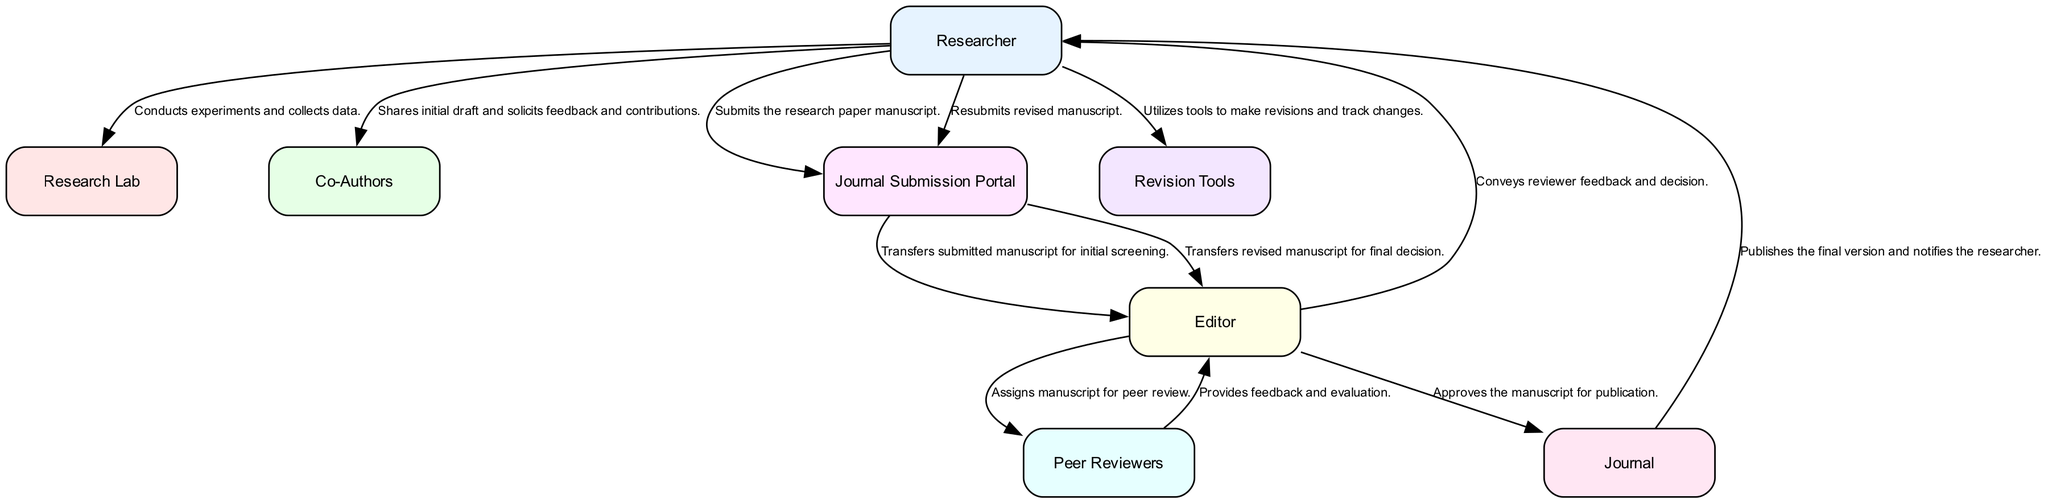What is the role of the Researcher in the diagram? The Researcher initiates the journey of the research paper by conceiving ideas, collecting data, drafting the manuscript, and later, responding to feedback and making revisions.
Answer: Initiator of the research paper How many entities are represented in the diagram? The diagram shows a total of eight entities that play a role in the journey of the research paper from concept to publication.
Answer: Eight What is the first flow of data in the process? The first flow involves the Researcher conducting experiments and collecting data, which is represented as the initial action in the diagram.
Answer: Conducts experiments and collects data Which entity receives feedback from the Peer Reviewers? The Editor receives evaluation and feedback from Peer Reviewers, which is an essential step before communicating with the Researcher.
Answer: Editor What tool does the Researcher use to make revisions? The Researcher utilizes Revision Tools to format, edit, and track changes to the manuscript following feedback from the Editor.
Answer: Revision Tools How does the submitted manuscript move to the Editor? The flow from the Journal Submission Portal to the Editor indicates that the submitted manuscript is transferred for initial screening.
Answer: Transfers submitted manuscript for initial screening What is the final stage of the paper's journey in the diagram? The final stage involves the Journal approving the manuscript for publication and notifying the Researcher of the published version.
Answer: Publishes the final version Which two types of collaborators does the Researcher engage with during drafting? The Researcher engages with Co-Authors for feedback and contributions while drafting the manuscript, which is essential for collaboration.
Answer: Co-Authors What decision does the Editor convey to the Researcher? The Editor conveys the reviewer feedback and decision regarding the manuscript's acceptance or required revisions back to the Researcher.
Answer: Reviewer feedback and decision 